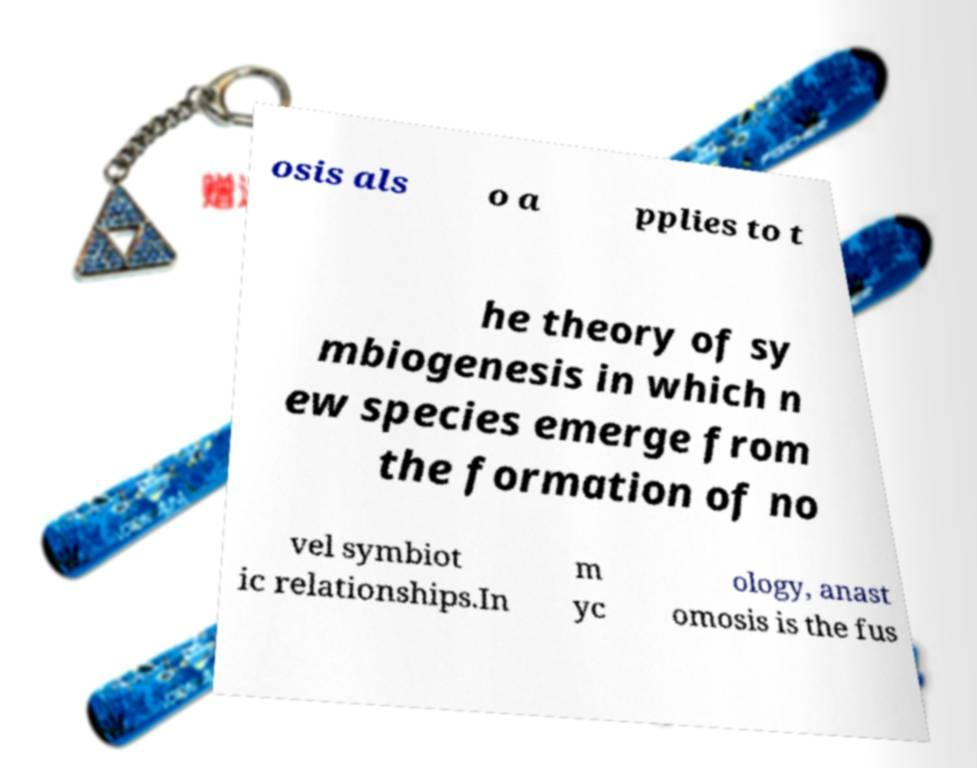What messages or text are displayed in this image? I need them in a readable, typed format. osis als o a pplies to t he theory of sy mbiogenesis in which n ew species emerge from the formation of no vel symbiot ic relationships.In m yc ology, anast omosis is the fus 